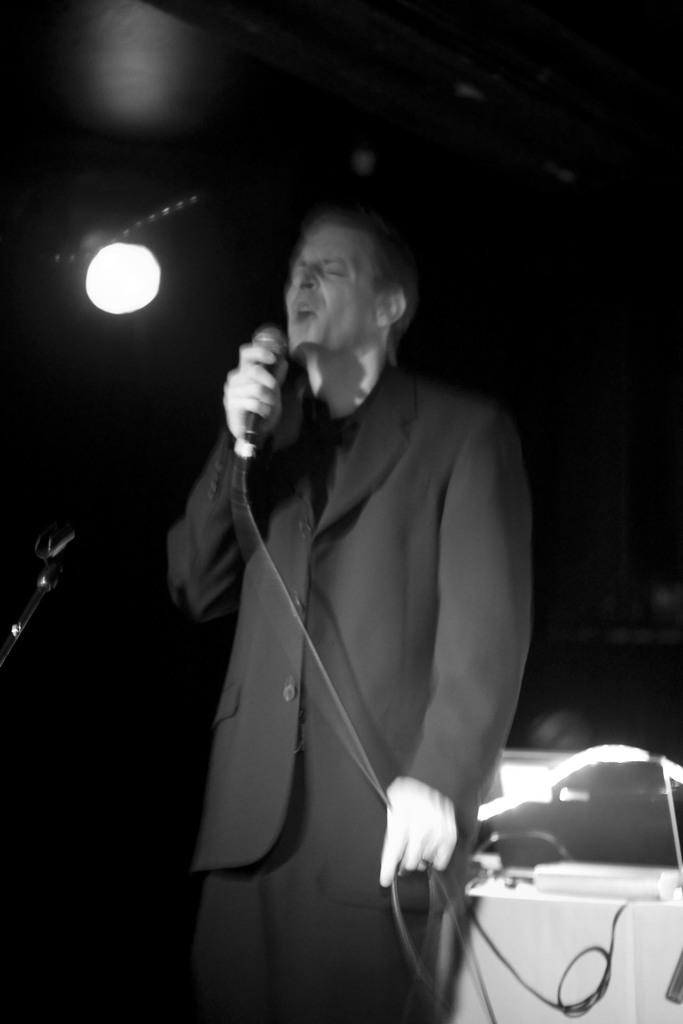What is the main subject of the image? There is a man standing in the center of the image. What is the man wearing? The man is wearing a suit. What is the man holding in his hand? The man is holding a microphone in his hand. What is the man doing in the image? The man is singing a song. Can you see the man's nose in the image? The man's nose is not specifically mentioned in the provided facts, but it is likely that his nose is visible in the image. However, the question itself is not directly answerable based on the given facts. 